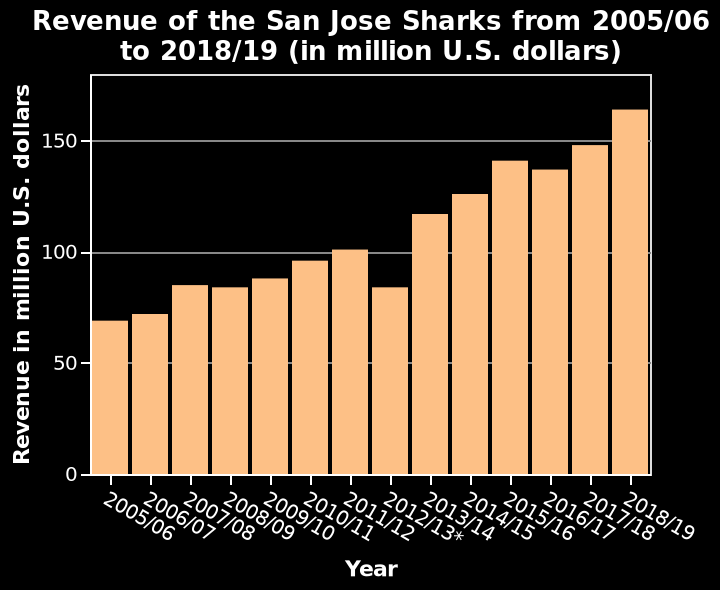<image>
Describe the following image in detail Revenue of the San Jose Sharks from 2005/06 to 2018/19 (in million U.S. dollars) is a bar graph. There is a categorical scale with 2005/06 on one end and 2018/19 at the other on the x-axis, labeled Year. The y-axis measures Revenue in million U.S. dollars along a linear scale of range 0 to 150. What is being measured on the x-axis of the bar graph? The x-axis of the bar graph is labeled Year and measures the time period from 2005/06 to 2018/19. Offer a thorough analysis of the image. The trend that mostly stands out to me is that there is a constant incline in revenue over the course of 4 years. However there are three instances as you can see in 2008/2009, 2012/2013 and 2016/2017 that shows also every 4 years they go into a decline in revenue. 